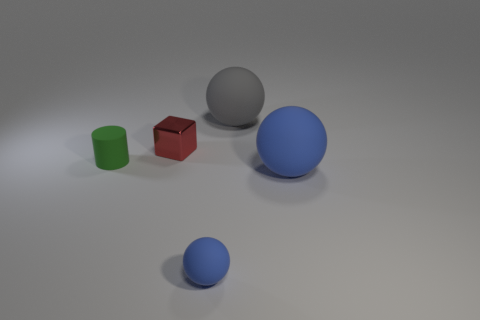Add 4 things. How many objects exist? 9 Subtract all small spheres. How many spheres are left? 2 Subtract 1 blocks. How many blocks are left? 0 Subtract all gray spheres. How many spheres are left? 2 Subtract all balls. How many objects are left? 2 Subtract all cyan blocks. How many gray balls are left? 1 Subtract all small brown cylinders. Subtract all large rubber things. How many objects are left? 3 Add 5 cylinders. How many cylinders are left? 6 Add 1 tiny red cubes. How many tiny red cubes exist? 2 Subtract 0 green cubes. How many objects are left? 5 